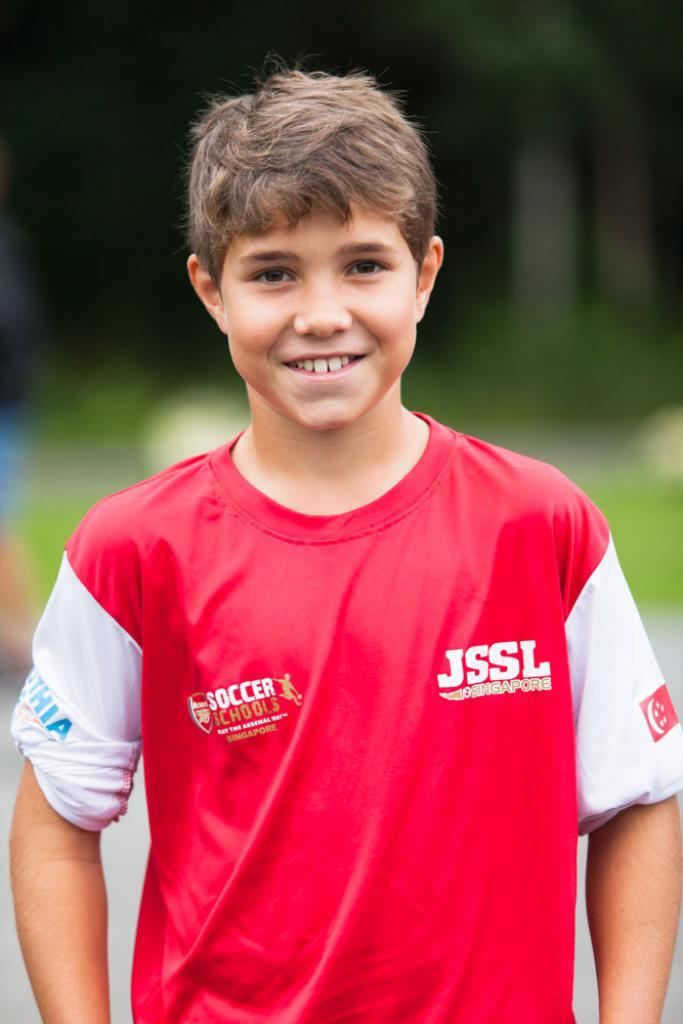<image>
Create a compact narrative representing the image presented. boy wearing red and white shirt with soccer schools and jssl singapore on it 